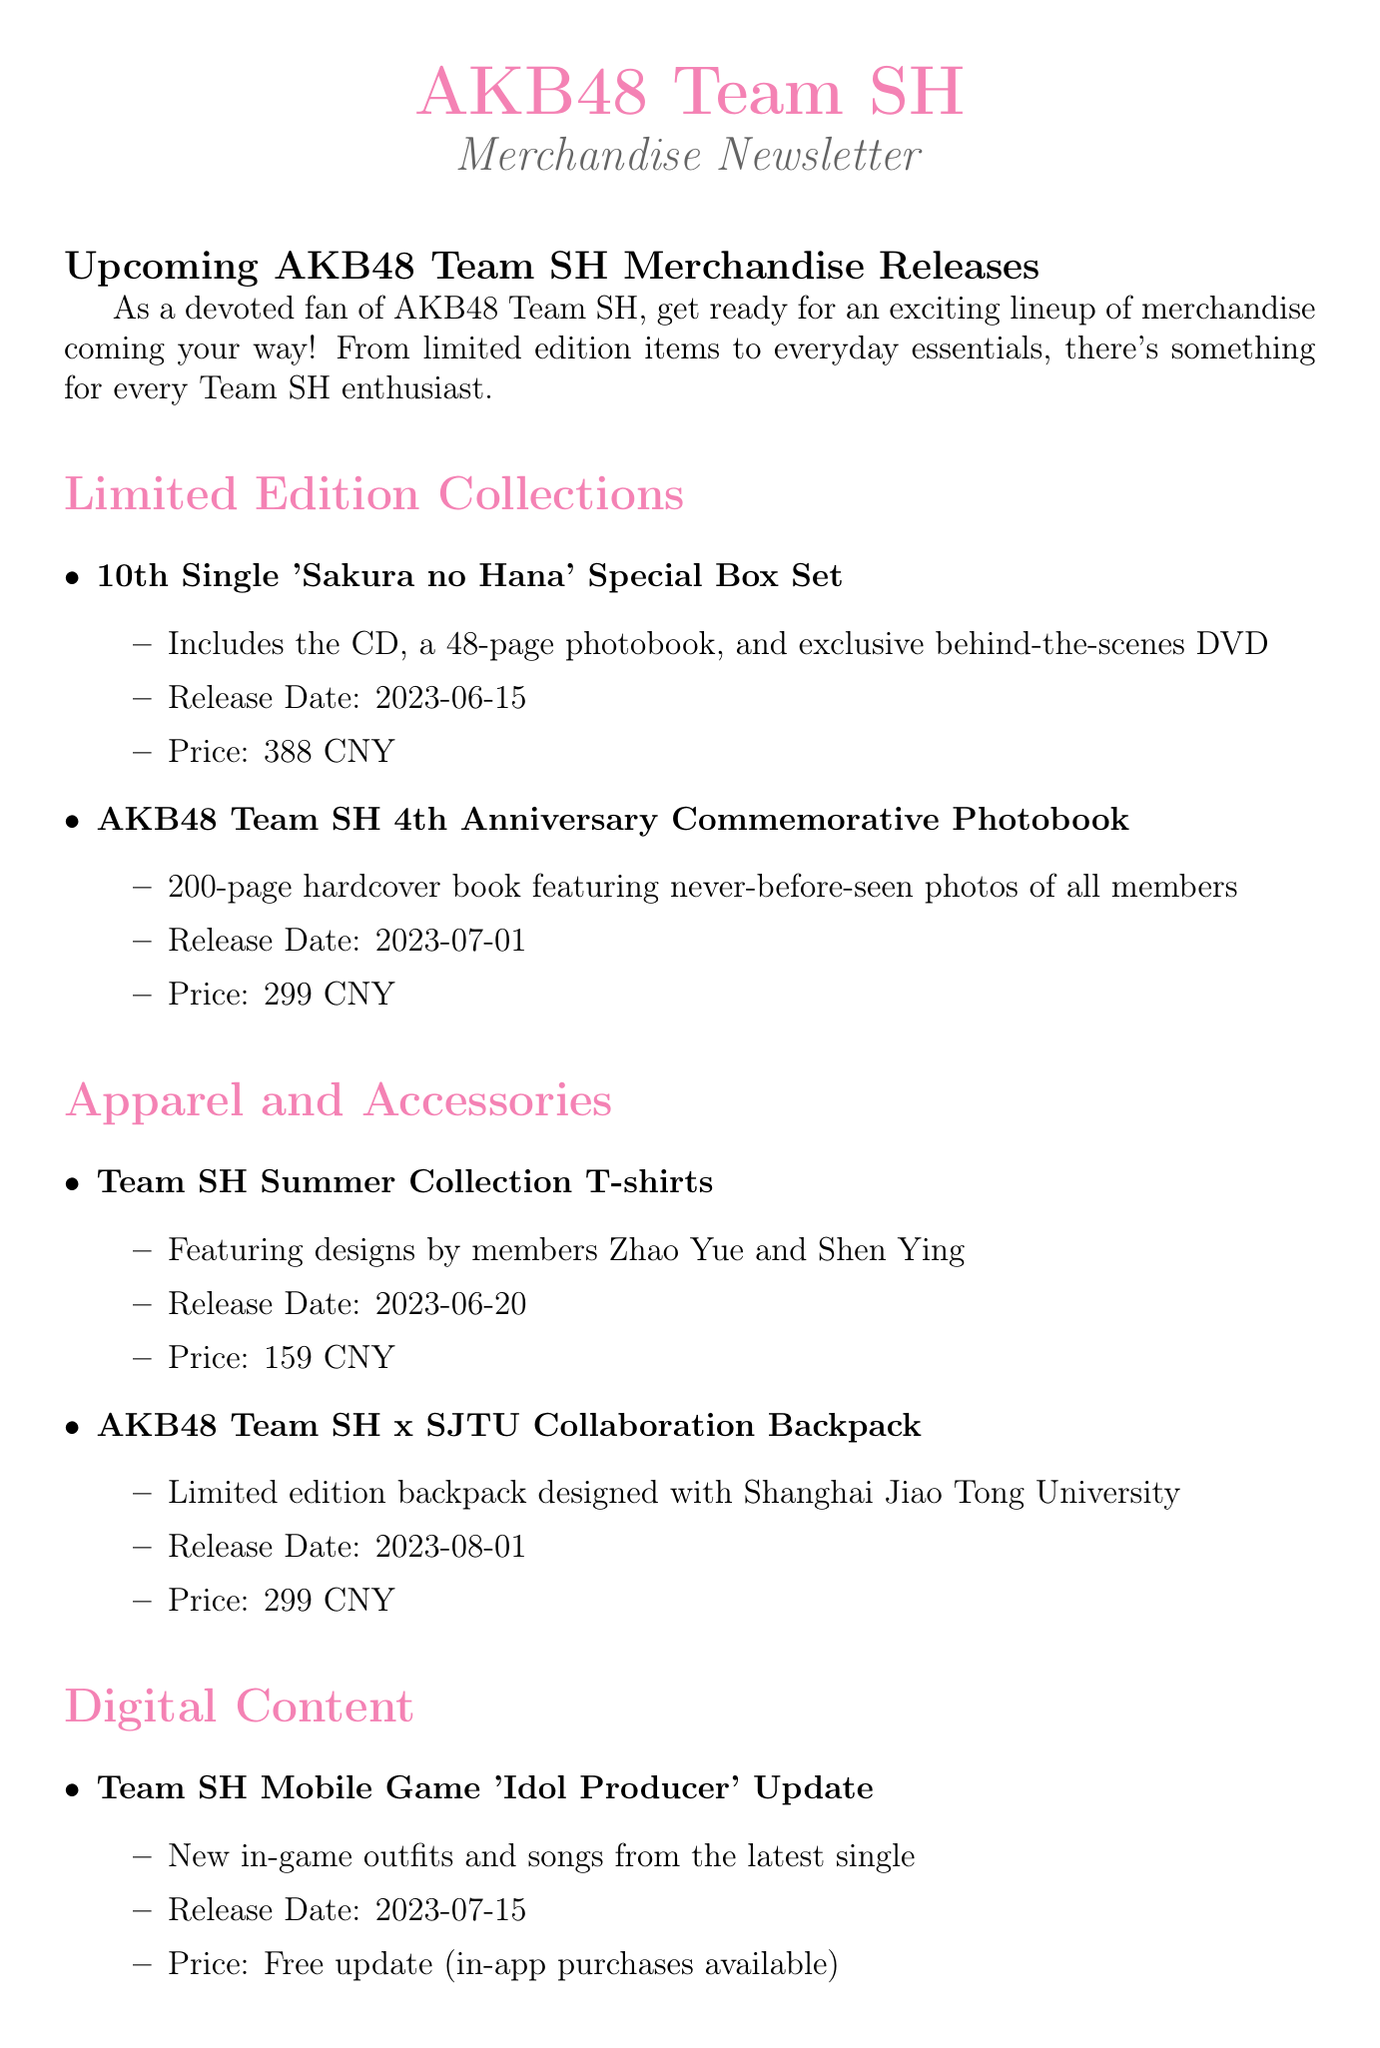What is the release date of the "10th Single 'Sakura no Hana' Special Box Set"? The document specifies the release date for this item as June 15, 2023.
Answer: June 15, 2023 What is included in the AKB48 Team SH 4th Anniversary Commemorative Photobook? The document mentions that it includes never-before-seen photos of all members over 200 pages.
Answer: 200-page hardcover book featuring never-before-seen photos of all members How much does the Team SH Summer Collection T-shirt cost? The cost of the T-shirt is stated in the document as 159 CNY.
Answer: 159 CNY What is the price for Virtual Meet & Greet Tickets? The document clearly outlines the price for these tickets as 88 CNY per session.
Answer: 88 CNY per session When will the AKB48 Team SH x Nendo Collaboration Figurines be released? The document indicates the release date for this collectible as September 1, 2023.
Answer: September 1, 2023 What bonus do pre-orders receive? According to the document, pre-orders receive a special Team SH clear file and a chance to win a signed polaroid.
Answer: Team SH clear file and a chance to win a signed polaroid Where can fans buy AKB48 Team SH merchandise? The document specifies that merchandise can be purchased on the official AKB48 Team SH Tmall store and at the AKB48 Team SH Theater.
Answer: Official AKB48 Team SH Tmall store and AKB48 Team SH Theater How many random cards are included in the Team SH 2023 Trading Card Set? The document mentions that the set includes 10 random cards featuring all current members.
Answer: 10 random cards 